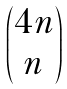Convert formula to latex. <formula><loc_0><loc_0><loc_500><loc_500>\begin{pmatrix} 4 n \\ n \end{pmatrix}</formula> 